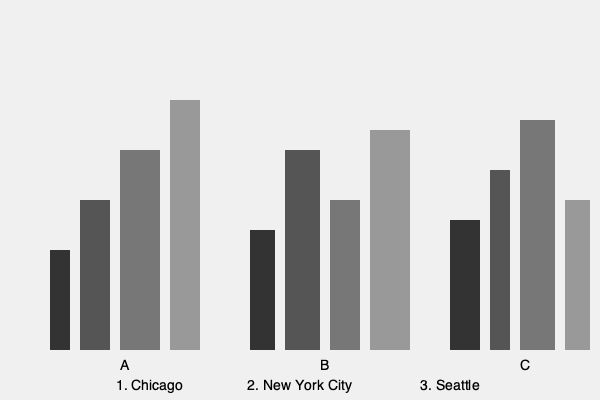Match the city skylines (A, B, C) to their corresponding place names (1, 2, 3) based on your knowledge of distinctive urban landscapes and architectural features. To match the city skylines to their corresponding place names, we need to analyze the distinctive features of each skyline and compare them to the known characteristics of the given cities:

1. Skyline A:
   - Has a mix of medium and tall buildings
   - One prominent tall building (likely the Willis Tower)
   - Relatively compact skyline
   This matches the characteristics of Chicago, known for its iconic Willis Tower and dense downtown area.

2. Skyline B:
   - Features several tall buildings of varying heights
   - Has the most skyscrapers among the three skylines
   - Densely packed buildings
   This corresponds to New York City, famous for its numerous skyscrapers and dense urban landscape.

3. Skyline C:
   - Has one very tall, distinctive building (likely the Space Needle)
   - Fewer tall buildings compared to A and B
   - More spread out skyline
   This matches Seattle, known for its iconic Space Needle and less dense downtown area compared to Chicago or New York.

Based on these observations, we can conclude:
A - 1 (Chicago)
B - 2 (New York City)
C - 3 (Seattle)
Answer: A1, B2, C3 